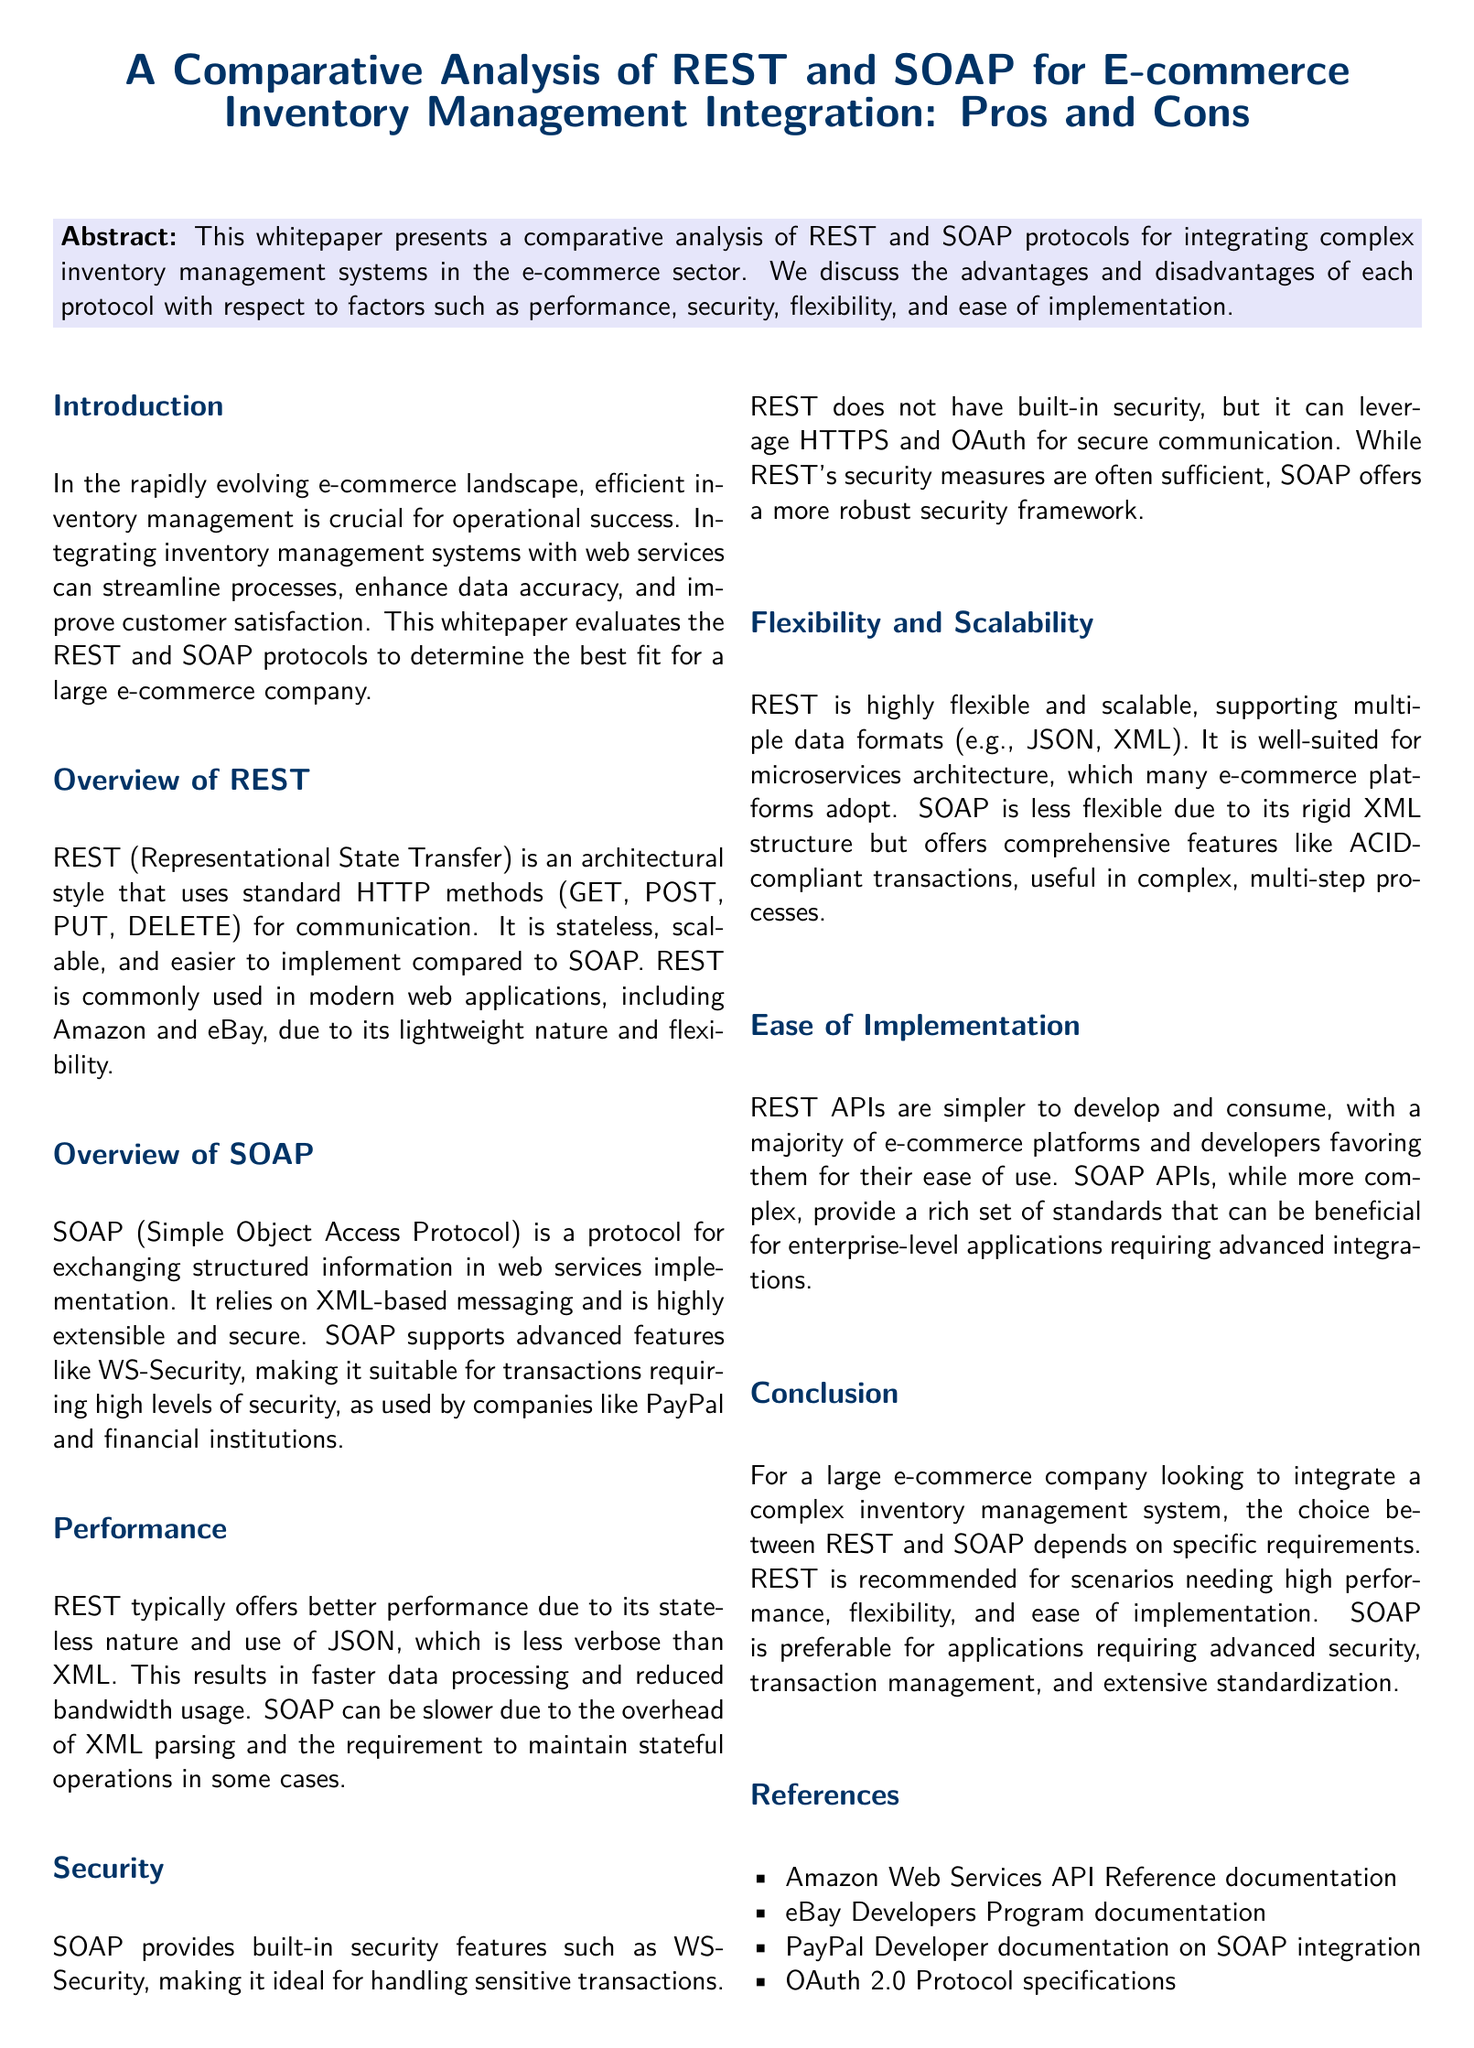What is the main focus of the whitepaper? The main focus is to analyze REST and SOAP protocols for e-commerce inventory management integration.
Answer: e-commerce inventory management integration What is the architectural style used by REST? REST is described as an architectural style that uses standard HTTP methods for communication.
Answer: architectural style Which format does SOAP primarily rely on for messaging? SOAP relies on XML-based messaging for exchanging structured information.
Answer: XML What is a significant performance advantage of REST over SOAP? REST typically offers better performance due to its stateless nature and use of a less verbose format.
Answer: better performance What built-in security feature does SOAP provide? SOAP provides WS-Security for robust security in transactions.
Answer: WS-Security Which protocol is recommended for applications requiring advanced security? The whitepaper recommends SOAP for applications needing advanced security.
Answer: SOAP What is a key benefit of REST's flexibility? REST supports multiple data formats, making it more flexible.
Answer: multiple data formats How does REST's ease of implementation compare to SOAP? REST APIs are simpler to develop and consume compared to SOAP APIs.
Answer: simpler What type of architecture is REST well-suited for? REST is well-suited for microservices architecture.
Answer: microservices architecture 